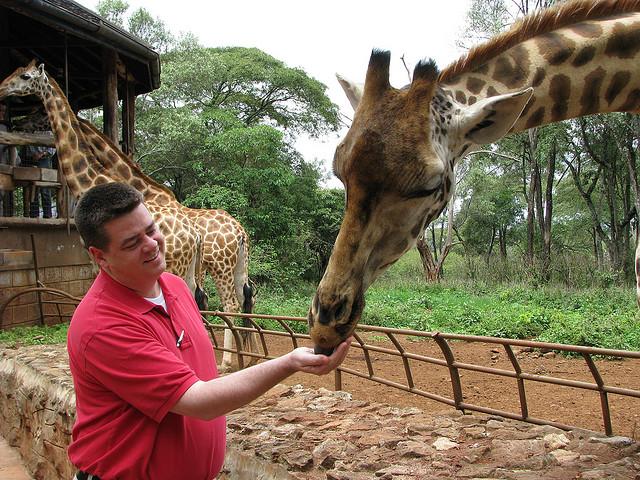Are the giraffes wild?
Write a very short answer. No. Does this man look happy?
Write a very short answer. Yes. How many people are there?
Give a very brief answer. 1. What is the man feeding?
Write a very short answer. Giraffe. 